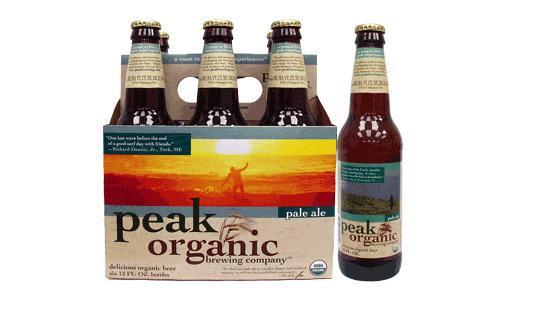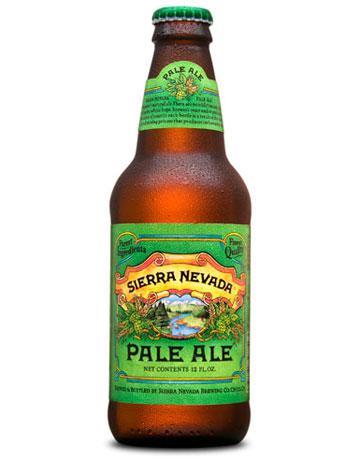The first image is the image on the left, the second image is the image on the right. For the images displayed, is the sentence "There are more than 10 bottles." factually correct? Answer yes or no. No. The first image is the image on the left, the second image is the image on the right. For the images shown, is this caption "There are more than ten bottles in total." true? Answer yes or no. No. 